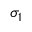Convert formula to latex. <formula><loc_0><loc_0><loc_500><loc_500>\sigma _ { 1 }</formula> 